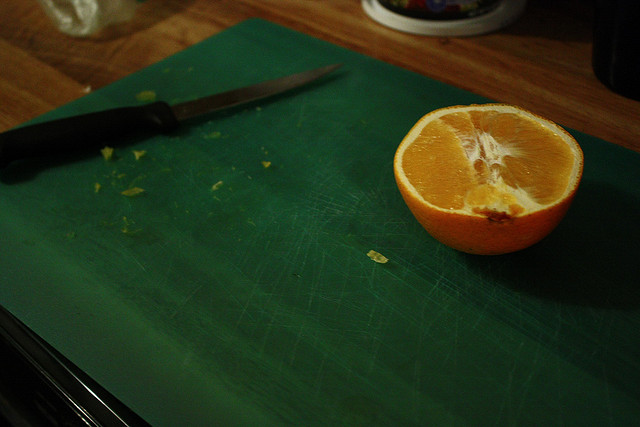What kind of orange is this? This appears to be a Navel orange, identifiable by its size and the characteristic navel-like formation on the non-stem end. 